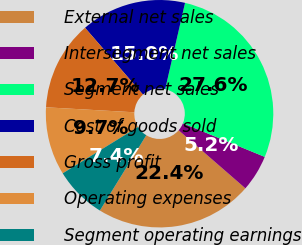Convert chart to OTSL. <chart><loc_0><loc_0><loc_500><loc_500><pie_chart><fcel>External net sales<fcel>Intersegment net sales<fcel>Segment net sales<fcel>Cost of goods sold<fcel>Gross profit<fcel>Operating expenses<fcel>Segment operating earnings<nl><fcel>22.4%<fcel>5.19%<fcel>27.6%<fcel>14.97%<fcel>12.73%<fcel>9.68%<fcel>7.43%<nl></chart> 